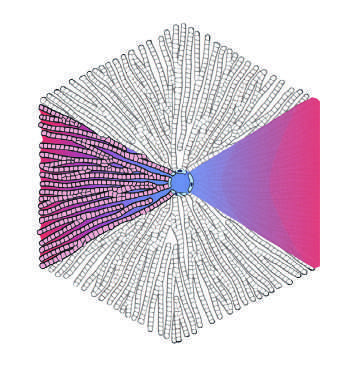do histologic appearance in active takayasu aortitis illustrating destruction and fibrosis of the arterial media refer to the regions of the parenchyma as periportal and centrilobular?
Answer the question using a single word or phrase. No 